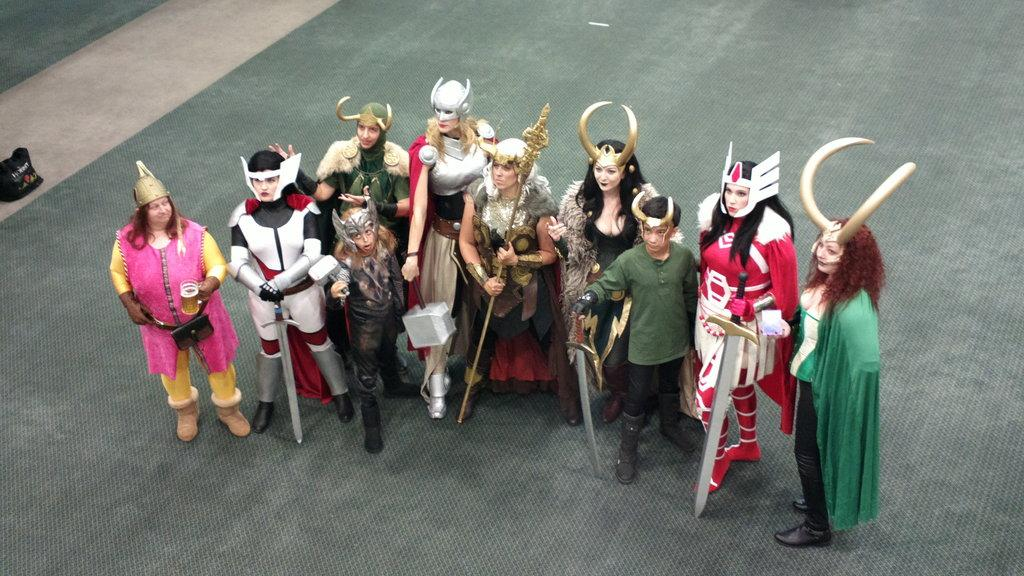What are the people in the image wearing? The people in the image are wearing costumes. Are there any specific accessories that some of the people are wearing? Yes, some of the people are wearing crowns. What are some of the people holding in the image? Some people are holding swords in the image. What can be seen on the left side of the image? There is an object on the left side of the image. What type of reward can be seen in the image? There is no reward present in the image. Is there a railway visible in the image? There is no railway present in the image. 